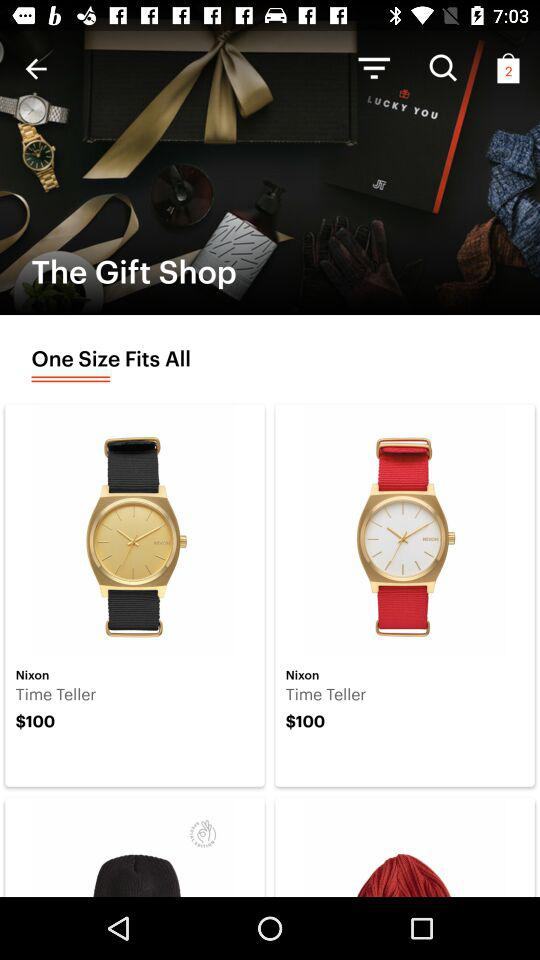What is the application name? The application name is "The Gift Shop". 